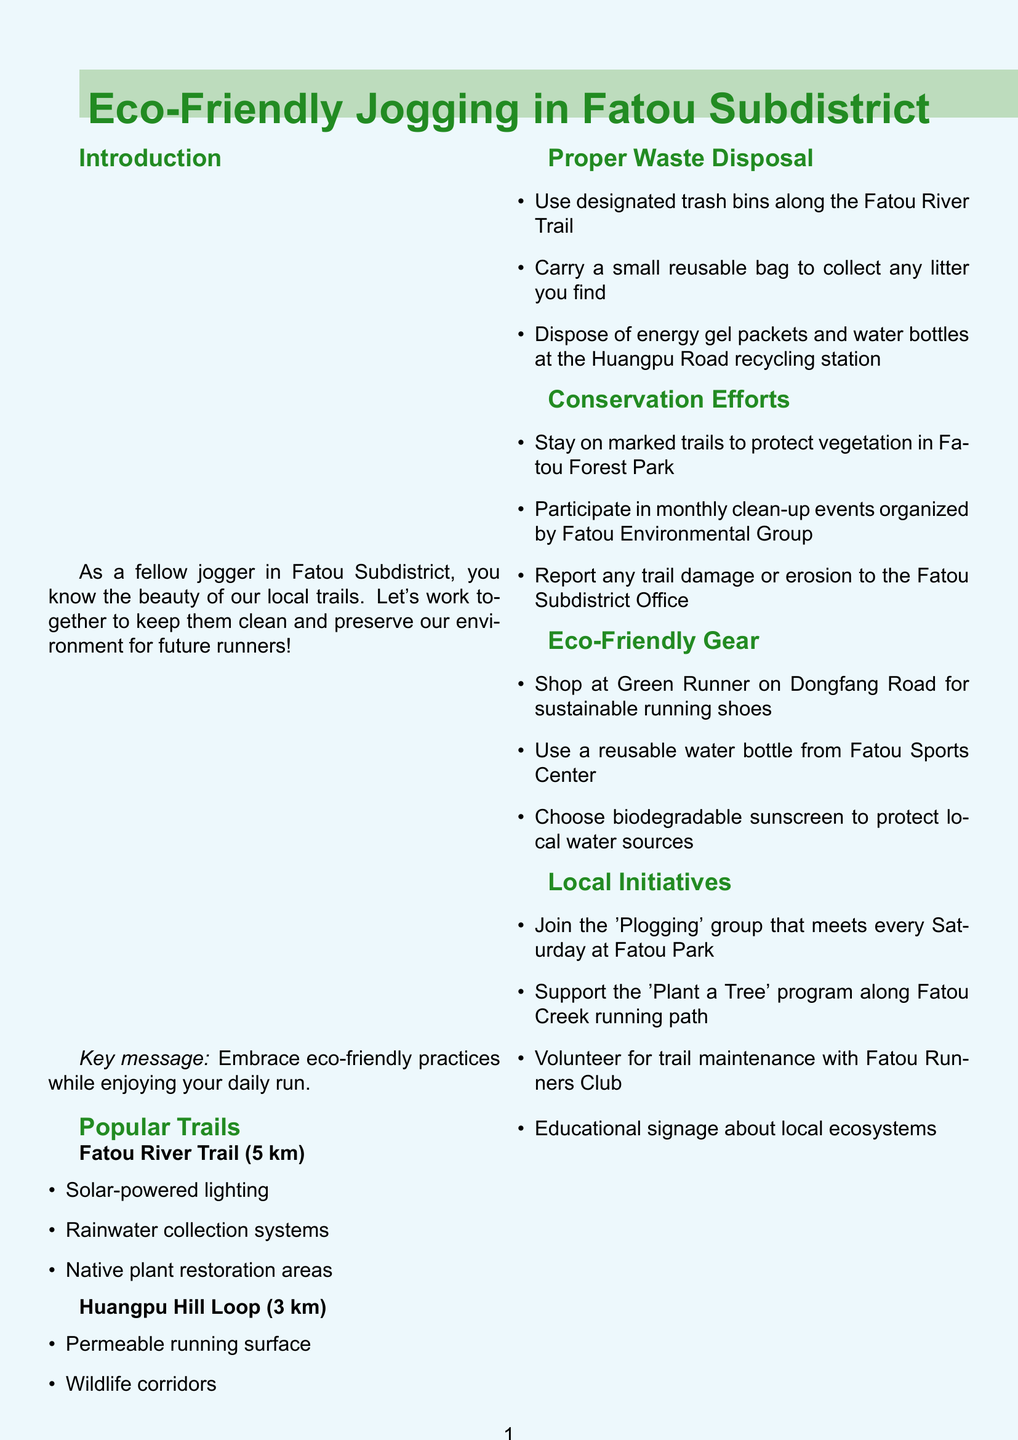What is the title of the brochure? The title is stated at the beginning of the document.
Answer: Eco-Friendly Jogging in Fatou Subdistrict What is the length of the Fatou River Trail? The length of the trail is mentioned in the popular trails section.
Answer: 5 km Where can joggers dispose of energy gel packets? This information is found under the proper waste disposal section.
Answer: Huangpu Road recycling station What eco-friendly store is suggested for sustainable running gear? The brochure lists a store in the local resources section.
Answer: Green Runner When is the community run and clean-up event? The specific date for the event is outlined in the call to action section.
Answer: First Sunday of every month What should joggers carry to collect litter? This detail is provided in the proper waste disposal content.
Answer: A small reusable bag Which trail has permeable running surfaces? The eco-features of the trails are listed in the popular trails section.
Answer: Huangpu Hill Loop What is the primary message of the introduction? The key message is emphasized at the end of the introduction section.
Answer: Embrace eco-friendly practices while enjoying your daily run 